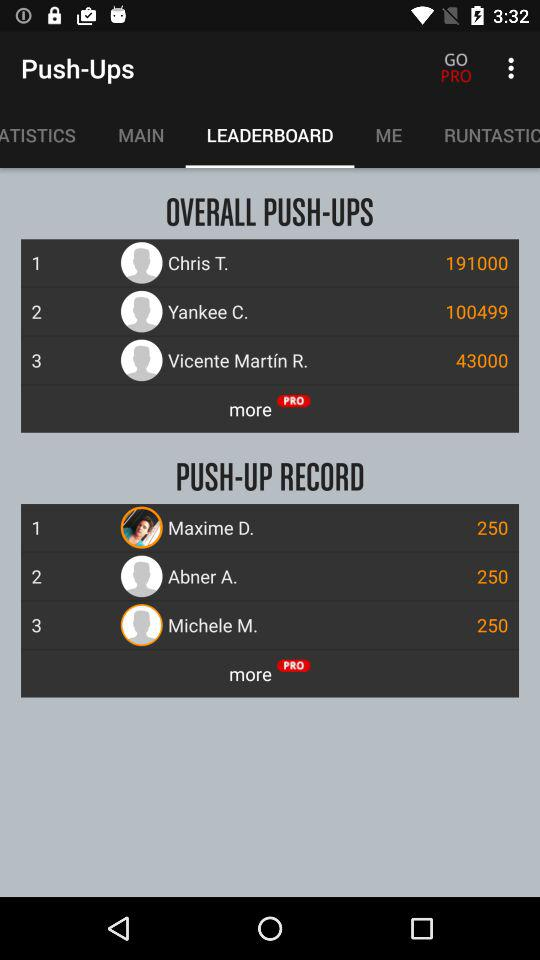How many overall push-ups has Chris T. done? Chris T. has done an overall 191000 push-ups. 